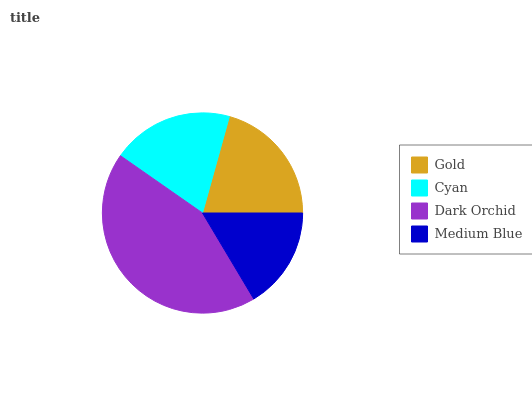Is Medium Blue the minimum?
Answer yes or no. Yes. Is Dark Orchid the maximum?
Answer yes or no. Yes. Is Cyan the minimum?
Answer yes or no. No. Is Cyan the maximum?
Answer yes or no. No. Is Gold greater than Cyan?
Answer yes or no. Yes. Is Cyan less than Gold?
Answer yes or no. Yes. Is Cyan greater than Gold?
Answer yes or no. No. Is Gold less than Cyan?
Answer yes or no. No. Is Gold the high median?
Answer yes or no. Yes. Is Cyan the low median?
Answer yes or no. Yes. Is Cyan the high median?
Answer yes or no. No. Is Gold the low median?
Answer yes or no. No. 